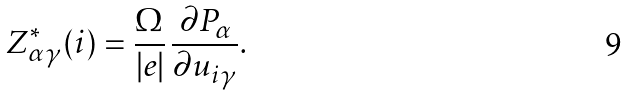<formula> <loc_0><loc_0><loc_500><loc_500>Z _ { \alpha \gamma } ^ { * } ( i ) = \frac { \Omega } { | e | } \, \frac { \partial P _ { \alpha } } { \partial u _ { i \gamma } } .</formula> 